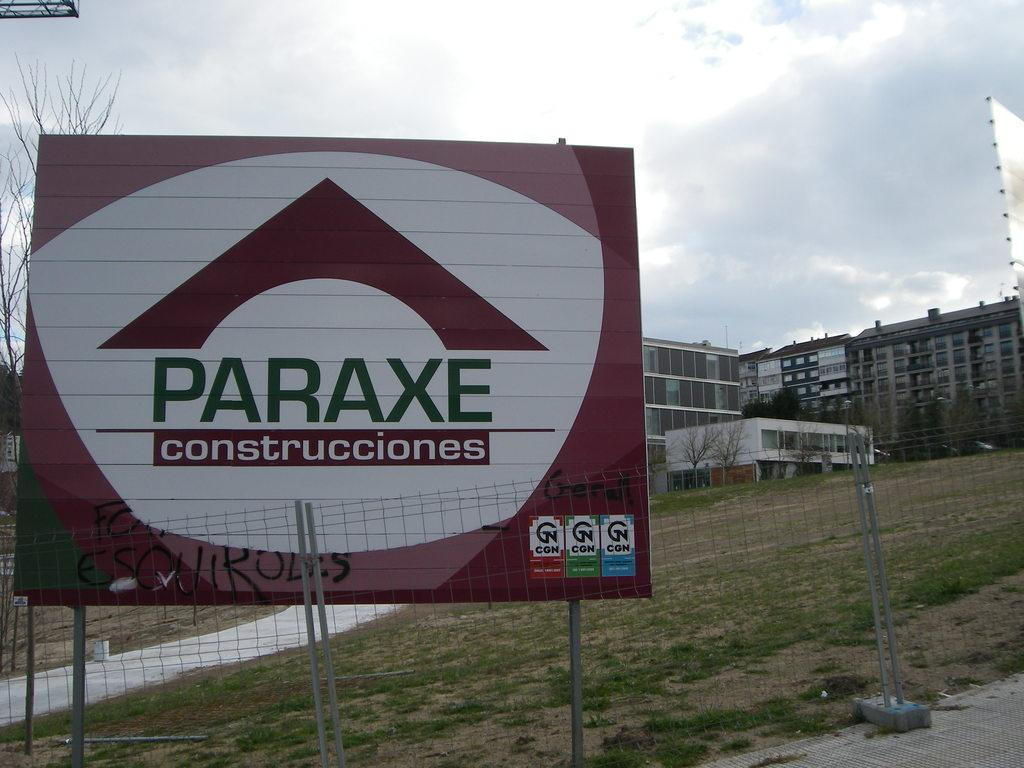<image>
Describe the image concisely. A Paraxe sign outside in the daytime on the grass 